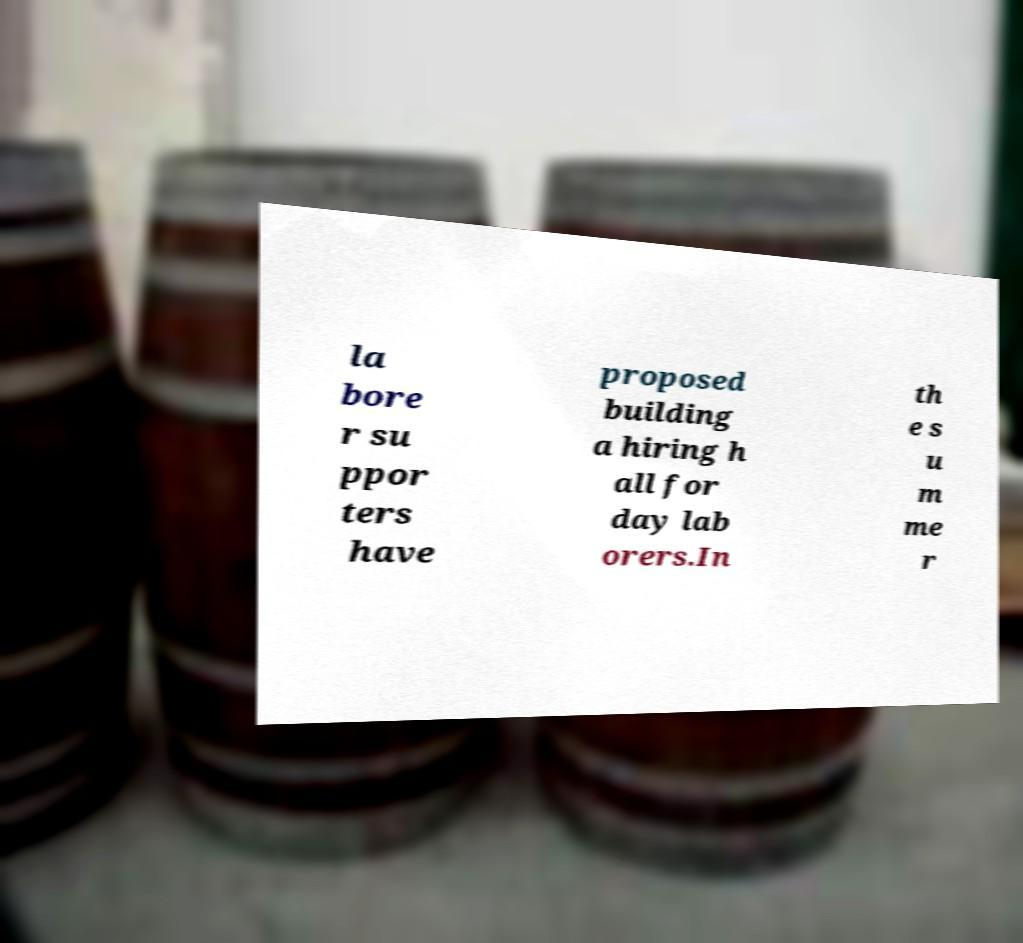Could you extract and type out the text from this image? la bore r su ppor ters have proposed building a hiring h all for day lab orers.In th e s u m me r 